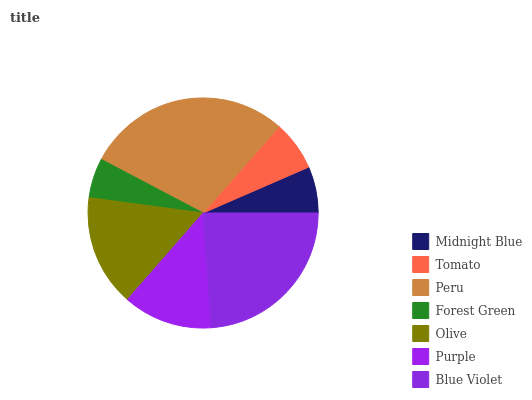Is Forest Green the minimum?
Answer yes or no. Yes. Is Peru the maximum?
Answer yes or no. Yes. Is Tomato the minimum?
Answer yes or no. No. Is Tomato the maximum?
Answer yes or no. No. Is Tomato greater than Midnight Blue?
Answer yes or no. Yes. Is Midnight Blue less than Tomato?
Answer yes or no. Yes. Is Midnight Blue greater than Tomato?
Answer yes or no. No. Is Tomato less than Midnight Blue?
Answer yes or no. No. Is Purple the high median?
Answer yes or no. Yes. Is Purple the low median?
Answer yes or no. Yes. Is Forest Green the high median?
Answer yes or no. No. Is Tomato the low median?
Answer yes or no. No. 